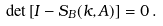<formula> <loc_0><loc_0><loc_500><loc_500>\det \left [ I - S _ { B } ( k , A ) \right ] = 0 \, .</formula> 